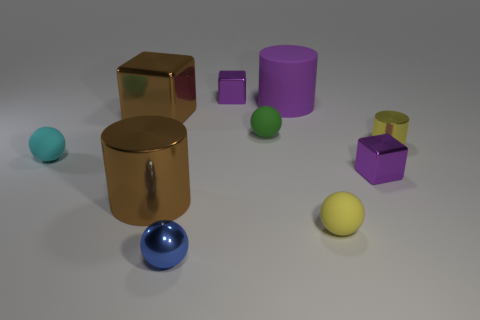Subtract all green spheres. How many spheres are left? 3 Subtract all brown spheres. Subtract all gray cylinders. How many spheres are left? 4 Subtract all cubes. How many objects are left? 7 Add 3 matte objects. How many matte objects exist? 7 Subtract 0 blue cylinders. How many objects are left? 10 Subtract all small purple things. Subtract all metal cubes. How many objects are left? 5 Add 3 small yellow spheres. How many small yellow spheres are left? 4 